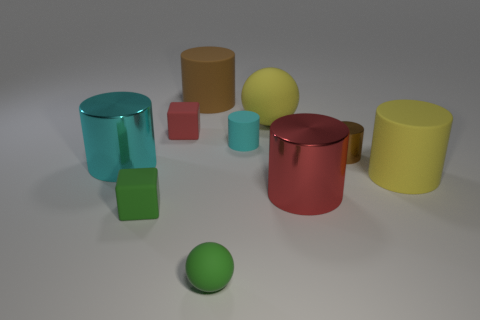How do the shadows in the image inform us about the light source? The direction and length of the shadows suggest that the light source is positioned to the top left of the scene, casting shadows diagonally toward the bottom right. 